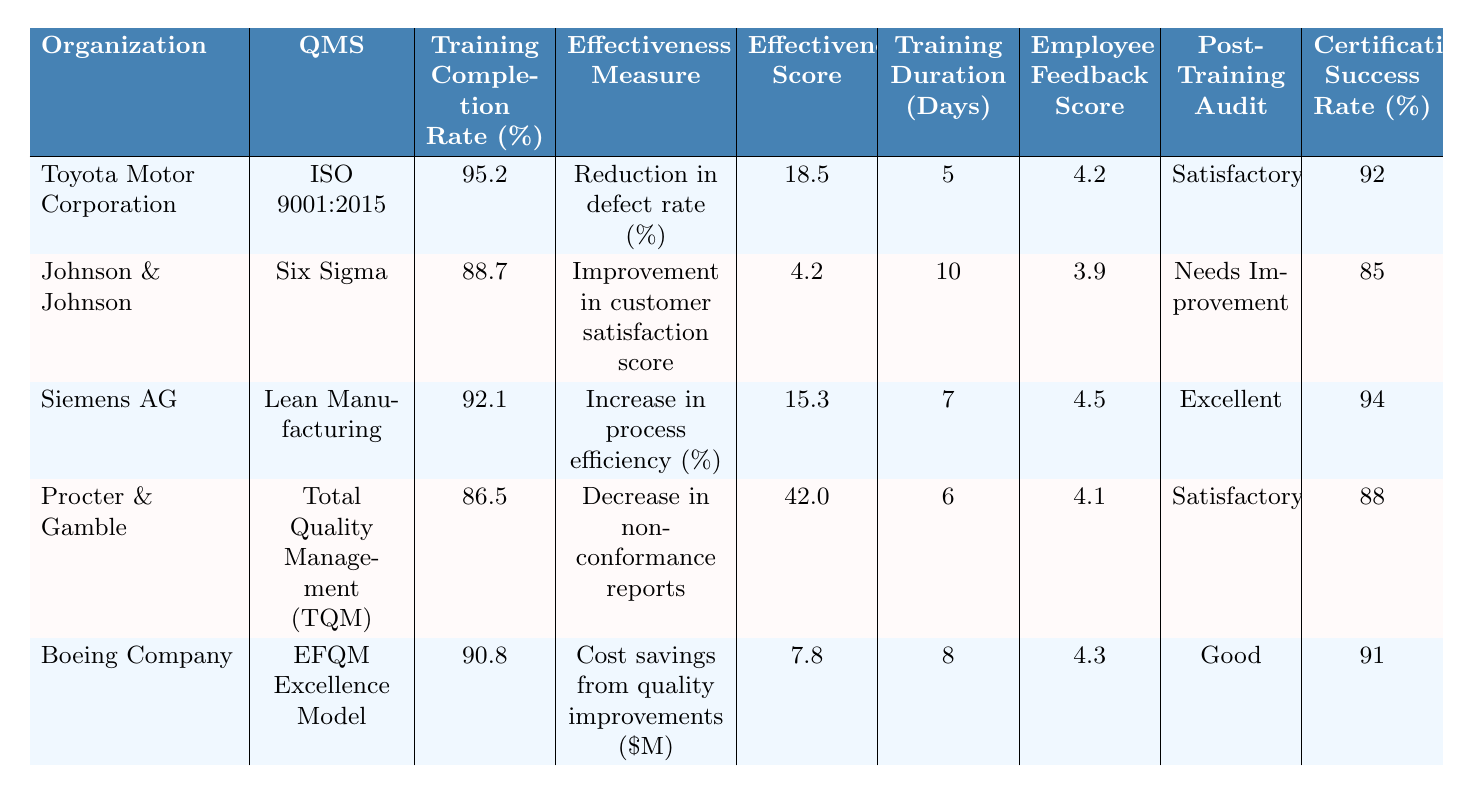What is the training completion rate for Siemens AG? The training completion rate for Siemens AG is listed in the table under the respective row, which shows a value of 92.1%.
Answer: 92.1 Which organization has the highest effectiveness score? By examining the effectiveness scores in each row, it is clear that Procter & Gamble has the highest effectiveness score at 42.
Answer: Procter & Gamble What is the average training completion rate of all the organizations? To find the average training completion rate, add all completion rates (95.2 + 88.7 + 92.1 + 86.5 + 90.8 = 453.3) and divide by the number of organizations (5). The average is 453.3 / 5 = 90.66.
Answer: 90.66 Is the post-training audit result for Johnson & Johnson satisfactory? The table indicates that the post-training audit result for Johnson & Johnson is "Needs Improvement," which is not satisfactory.
Answer: No What is the difference in training completion rates between Toyota Motor Corporation and Boeing Company? The training completion rate for Toyota Motor Corporation is 95.2% and for Boeing Company is 90.8%. The difference is calculated by subtracting Boeing's completion rate from Toyota's (95.2 - 90.8 = 4.4).
Answer: 4.4 Which organization has the lowest employee feedback score? Upon reviewing the employee feedback scores for each organization, Johnson & Johnson has the lowest score listed at 3.9.
Answer: Johnson & Johnson What is the total number of quality improvement projects initiated across all organizations? To find the total, sum the number of projects initiated by each organization (12 + 8 + 15 + 10 + 11 = 56).
Answer: 56 Which quality management system has the highest certification success rate? By checking the certification success rates, Siemens AG has the highest at 94%.
Answer: Siemens AG Is there a correlation between training duration and employee feedback scores? Upon reviewing the data, the training durations and feedback scores can be compared, but establishing correlation needs statistical analysis. However, visually, it appears that longer training duration does not guarantee higher feedback scores based on this data.
Answer: No clear correlation How many organizations have a training completion rate above 90%? From the table, Toyota Motor Corporation, Siemens AG, and Boeing Company have training completion rates above 90%. This is a total of 3 organizations.
Answer: 3 